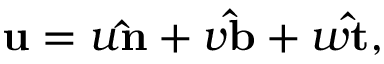<formula> <loc_0><loc_0><loc_500><loc_500>u = u \hat { n } + v \hat { b } + w \hat { t } ,</formula> 